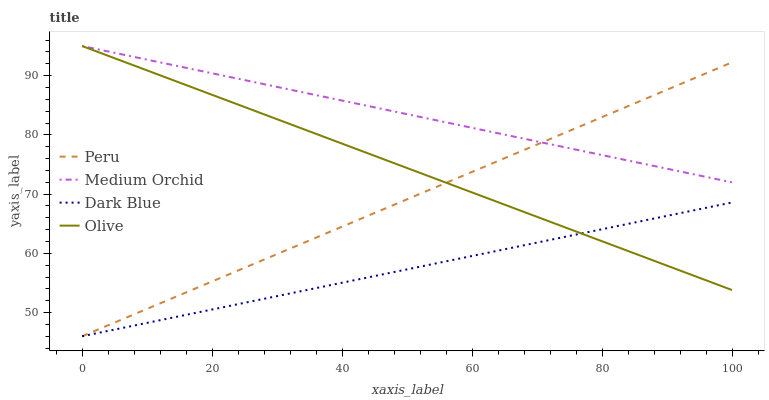Does Dark Blue have the minimum area under the curve?
Answer yes or no. Yes. Does Medium Orchid have the maximum area under the curve?
Answer yes or no. Yes. Does Medium Orchid have the minimum area under the curve?
Answer yes or no. No. Does Dark Blue have the maximum area under the curve?
Answer yes or no. No. Is Dark Blue the smoothest?
Answer yes or no. Yes. Is Olive the roughest?
Answer yes or no. Yes. Is Medium Orchid the smoothest?
Answer yes or no. No. Is Medium Orchid the roughest?
Answer yes or no. No. Does Dark Blue have the lowest value?
Answer yes or no. Yes. Does Medium Orchid have the lowest value?
Answer yes or no. No. Does Medium Orchid have the highest value?
Answer yes or no. Yes. Does Dark Blue have the highest value?
Answer yes or no. No. Is Dark Blue less than Medium Orchid?
Answer yes or no. Yes. Is Medium Orchid greater than Dark Blue?
Answer yes or no. Yes. Does Dark Blue intersect Olive?
Answer yes or no. Yes. Is Dark Blue less than Olive?
Answer yes or no. No. Is Dark Blue greater than Olive?
Answer yes or no. No. Does Dark Blue intersect Medium Orchid?
Answer yes or no. No. 